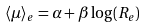<formula> <loc_0><loc_0><loc_500><loc_500>\langle \mu \rangle _ { e } = \alpha + \beta \log ( R _ { e } )</formula> 